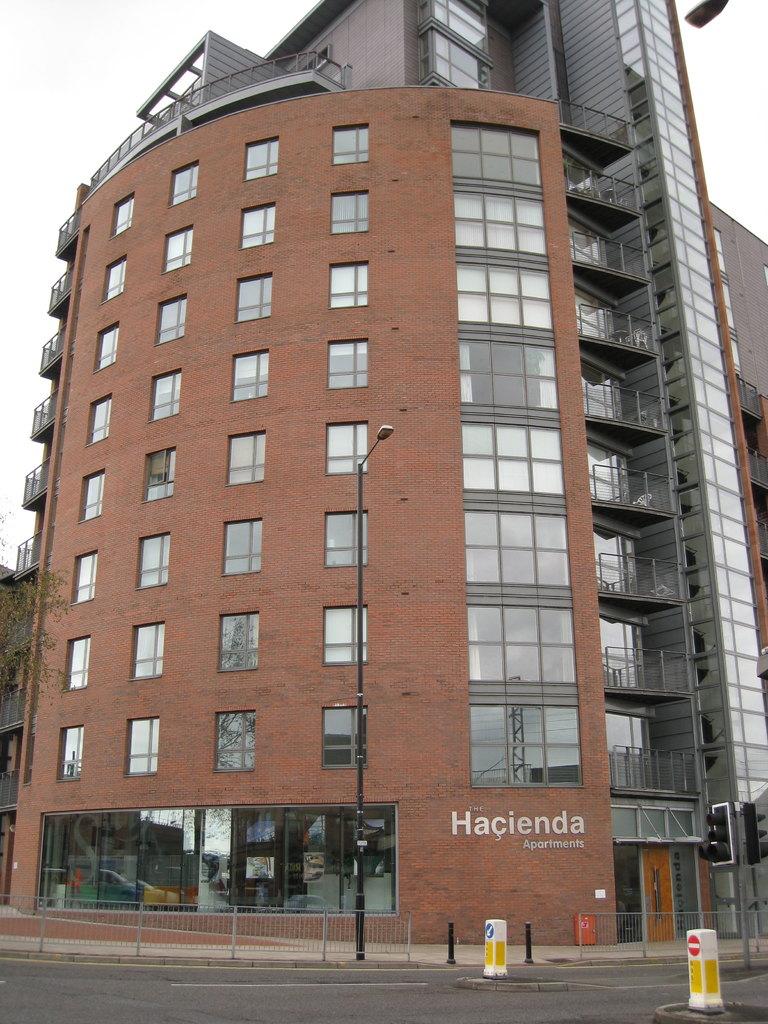What is the name written on this building?
Your answer should be compact. Hacienda. 